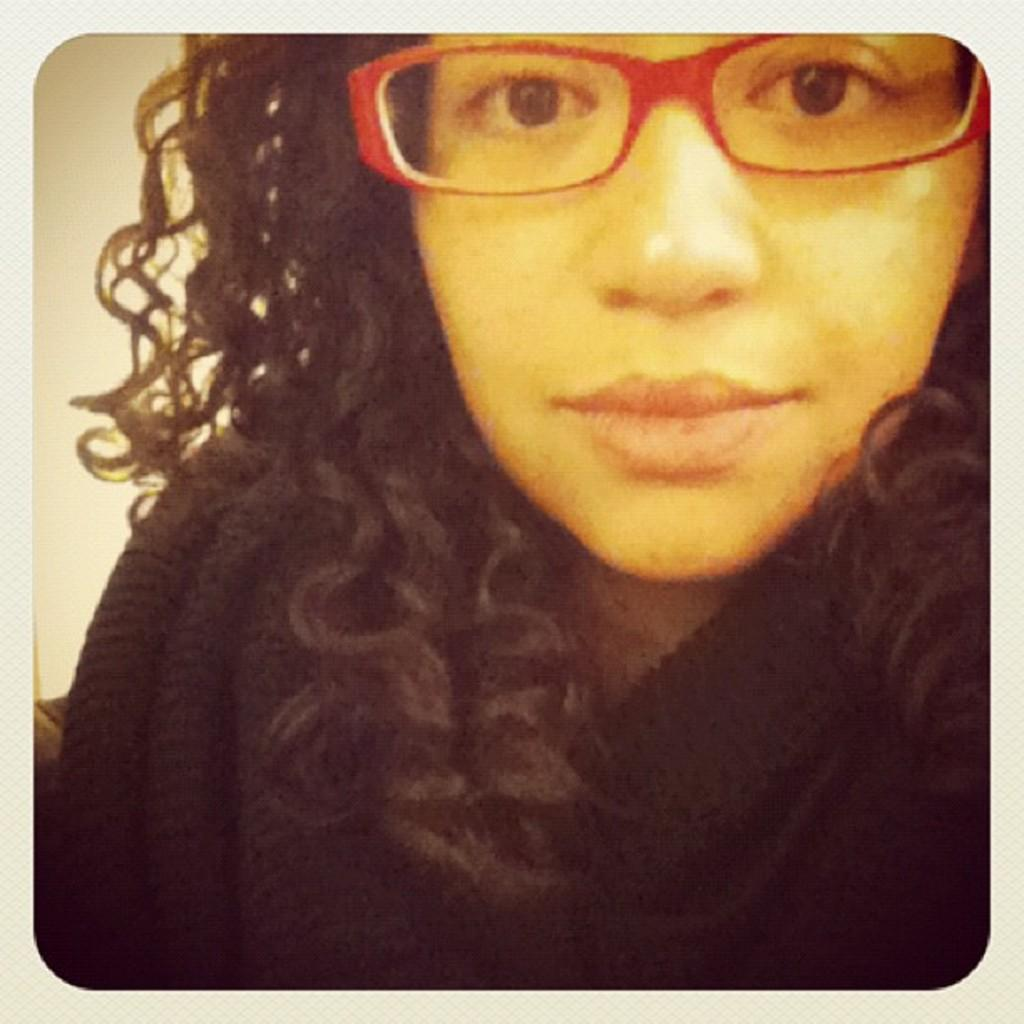Who is present in the image? There is a woman in the image. What is the woman wearing on her face? The woman is wearing specs. What can be seen in the background of the image? There is a wall visible in the image. What type of mitten is the woman wearing on her back in the image? There is no mitten visible on the woman's back in the image. 